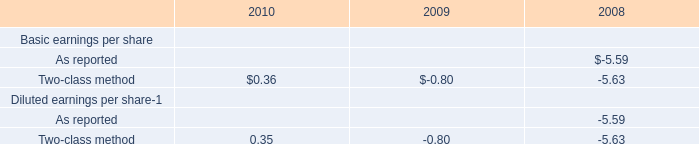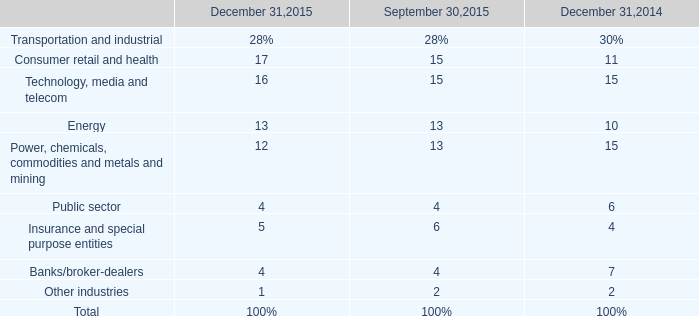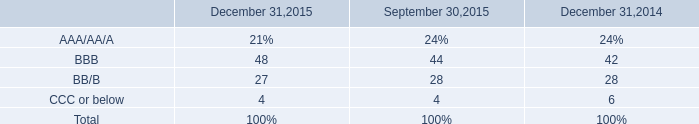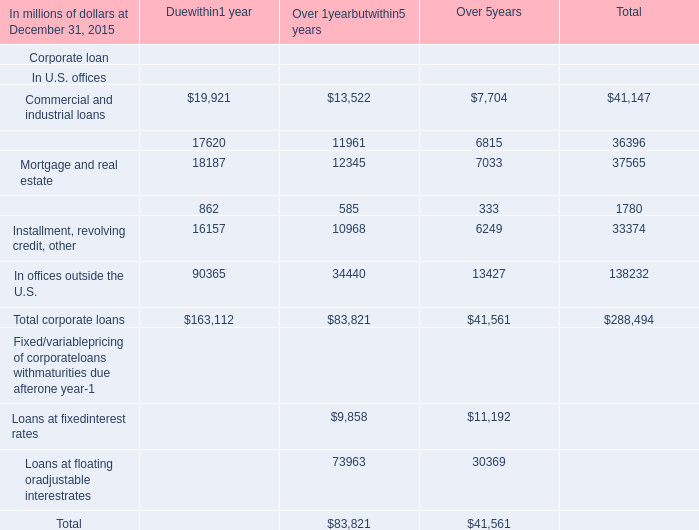What was the average ratio for Technology, media and telecom for December 31,2015, September 30,2015, and December 31,2014 ? 
Computations: ((((16 + 15) + 15) / 3) / 100)
Answer: 0.15333. 